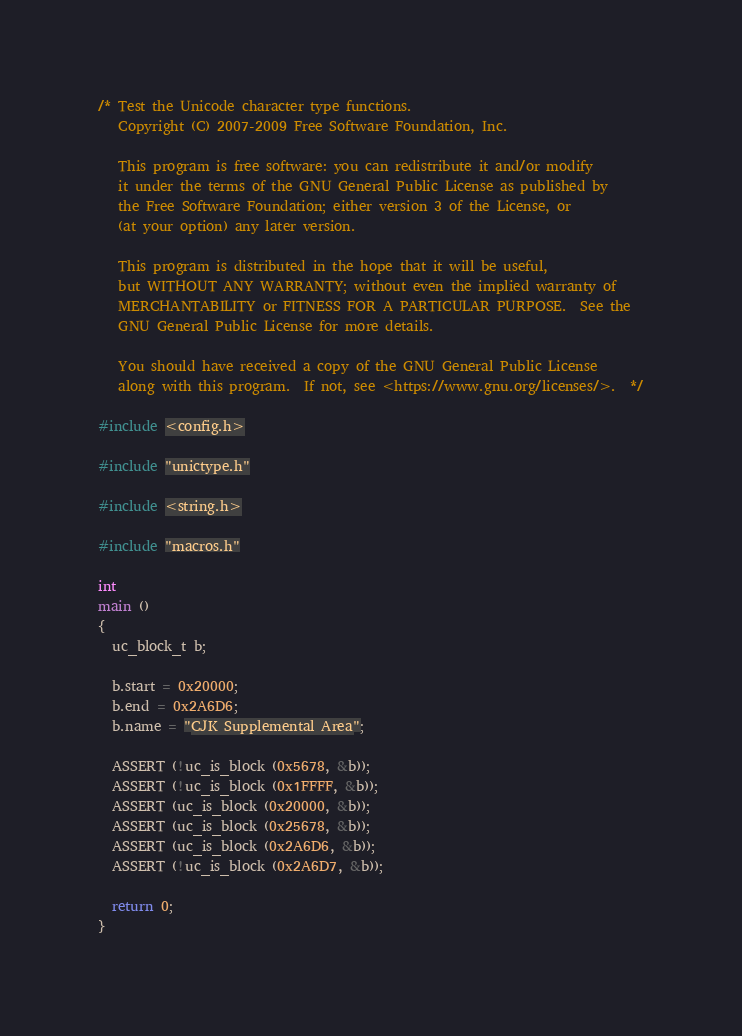<code> <loc_0><loc_0><loc_500><loc_500><_C_>/* Test the Unicode character type functions.
   Copyright (C) 2007-2009 Free Software Foundation, Inc.

   This program is free software: you can redistribute it and/or modify
   it under the terms of the GNU General Public License as published by
   the Free Software Foundation; either version 3 of the License, or
   (at your option) any later version.

   This program is distributed in the hope that it will be useful,
   but WITHOUT ANY WARRANTY; without even the implied warranty of
   MERCHANTABILITY or FITNESS FOR A PARTICULAR PURPOSE.  See the
   GNU General Public License for more details.

   You should have received a copy of the GNU General Public License
   along with this program.  If not, see <https://www.gnu.org/licenses/>.  */

#include <config.h>

#include "unictype.h"

#include <string.h>

#include "macros.h"

int
main ()
{
  uc_block_t b;

  b.start = 0x20000;
  b.end = 0x2A6D6;
  b.name = "CJK Supplemental Area";

  ASSERT (!uc_is_block (0x5678, &b));
  ASSERT (!uc_is_block (0x1FFFF, &b));
  ASSERT (uc_is_block (0x20000, &b));
  ASSERT (uc_is_block (0x25678, &b));
  ASSERT (uc_is_block (0x2A6D6, &b));
  ASSERT (!uc_is_block (0x2A6D7, &b));

  return 0;
}
</code> 